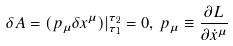<formula> <loc_0><loc_0><loc_500><loc_500>\delta A = ( p _ { \mu } \delta x ^ { \mu } ) { | } ^ { \tau _ { 2 } } _ { \tau _ { 1 } } = 0 , \, p _ { \mu } \equiv \frac { \partial L } { \partial \dot { x } ^ { \mu } }</formula> 